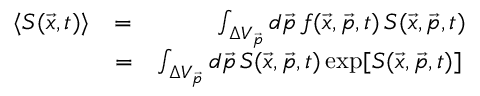Convert formula to latex. <formula><loc_0><loc_0><loc_500><loc_500>\begin{array} { r l r } { \langle S ( \vec { x } , t ) \rangle } & { = } & { \int _ { \Delta V _ { \vec { p } } } d \vec { p } \, f ( \vec { x } , \vec { p } , t ) \, S ( \vec { x } , \vec { p } , t ) } \\ & { = } & { \int _ { \Delta V _ { \vec { p } } } d \vec { p } \, S ( \vec { x } , \vec { p } , t ) \exp [ S ( \vec { x } , \vec { p } , t ) ] \, } \end{array}</formula> 